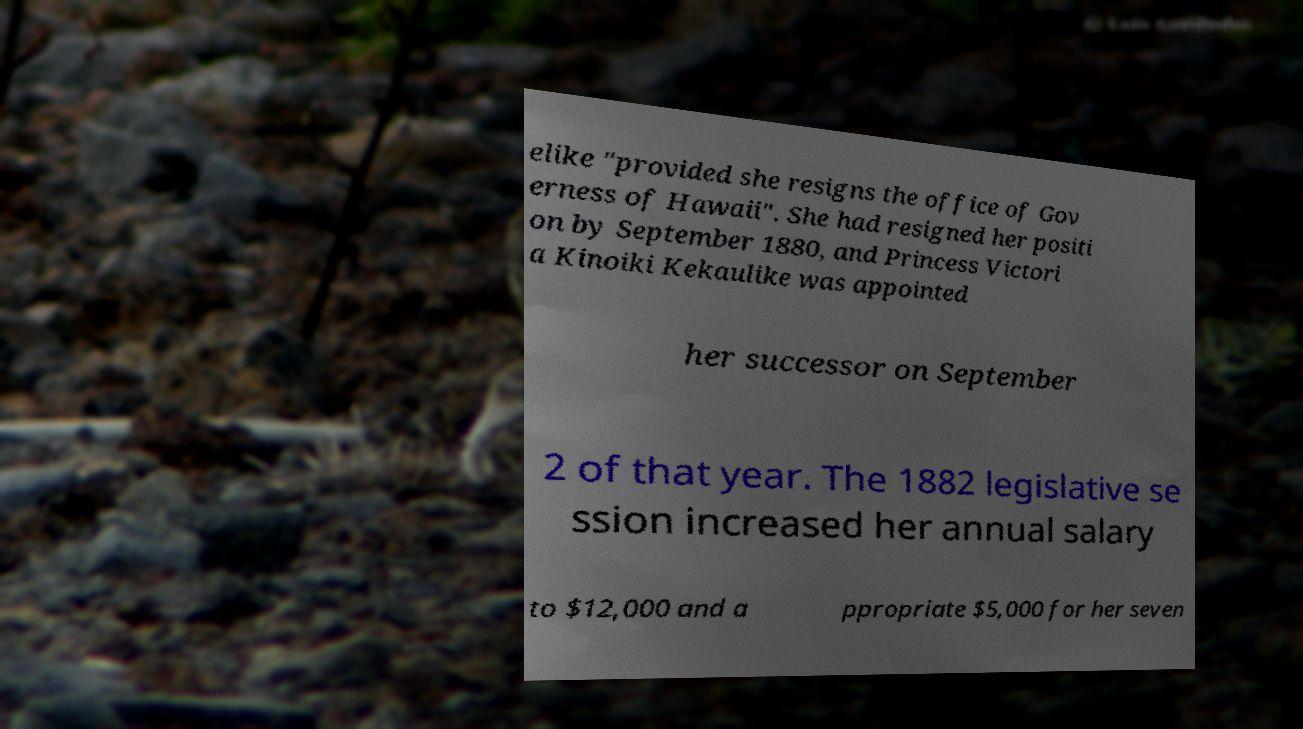Can you read and provide the text displayed in the image?This photo seems to have some interesting text. Can you extract and type it out for me? elike "provided she resigns the office of Gov erness of Hawaii". She had resigned her positi on by September 1880, and Princess Victori a Kinoiki Kekaulike was appointed her successor on September 2 of that year. The 1882 legislative se ssion increased her annual salary to $12,000 and a ppropriate $5,000 for her seven 